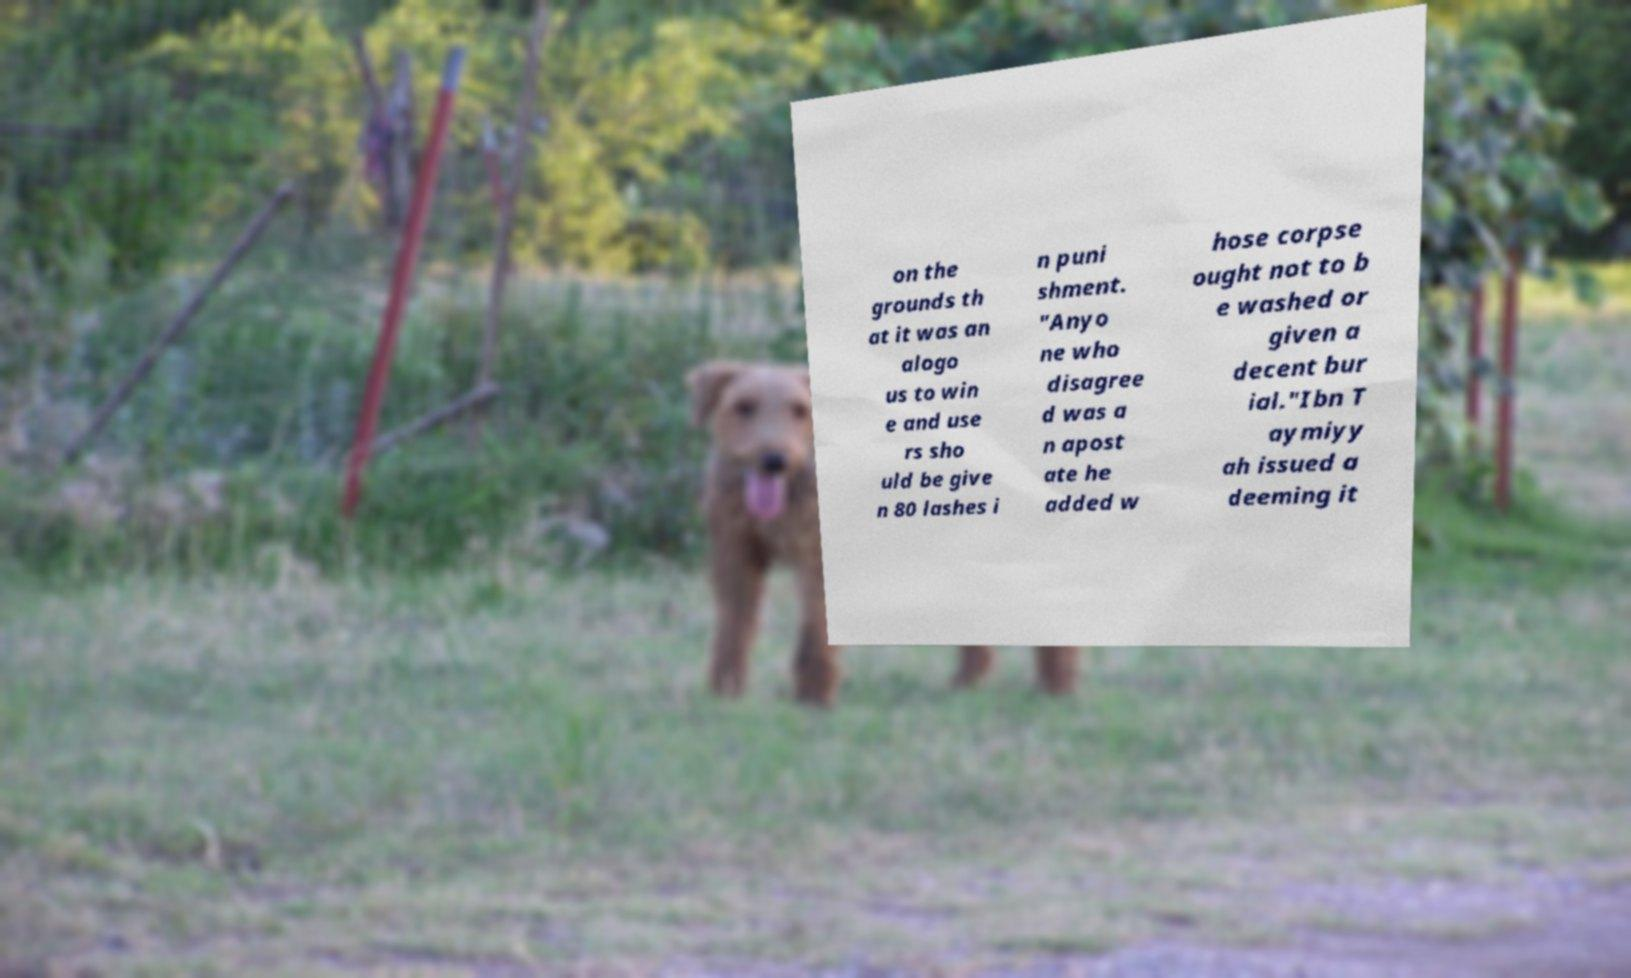Can you accurately transcribe the text from the provided image for me? on the grounds th at it was an alogo us to win e and use rs sho uld be give n 80 lashes i n puni shment. "Anyo ne who disagree d was a n apost ate he added w hose corpse ought not to b e washed or given a decent bur ial."Ibn T aymiyy ah issued a deeming it 